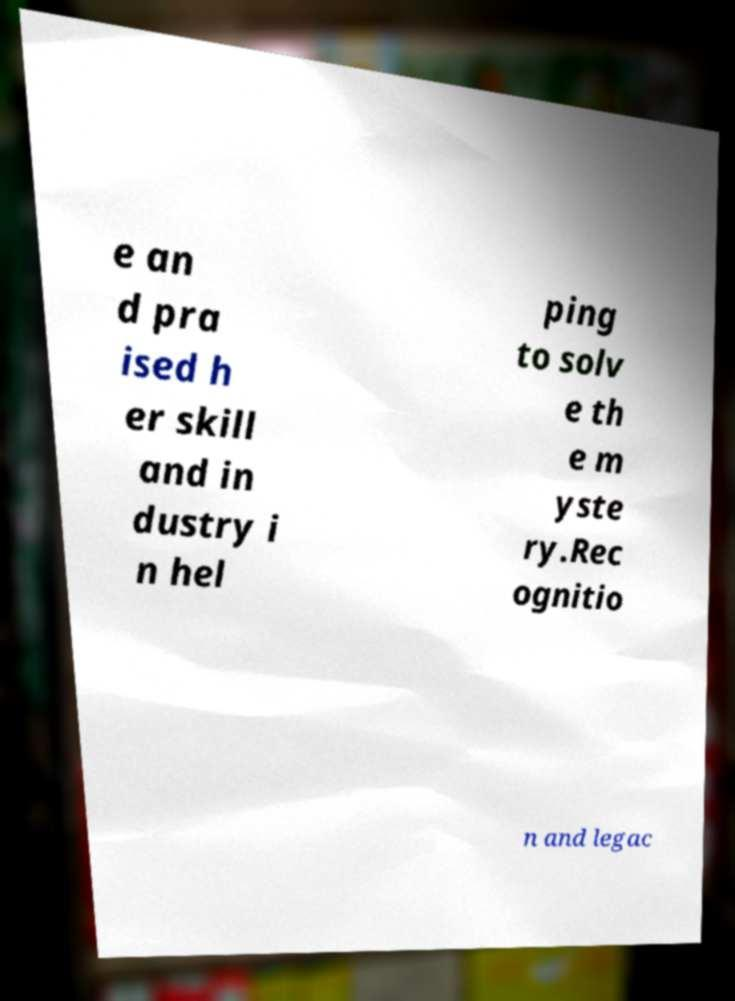What messages or text are displayed in this image? I need them in a readable, typed format. e an d pra ised h er skill and in dustry i n hel ping to solv e th e m yste ry.Rec ognitio n and legac 